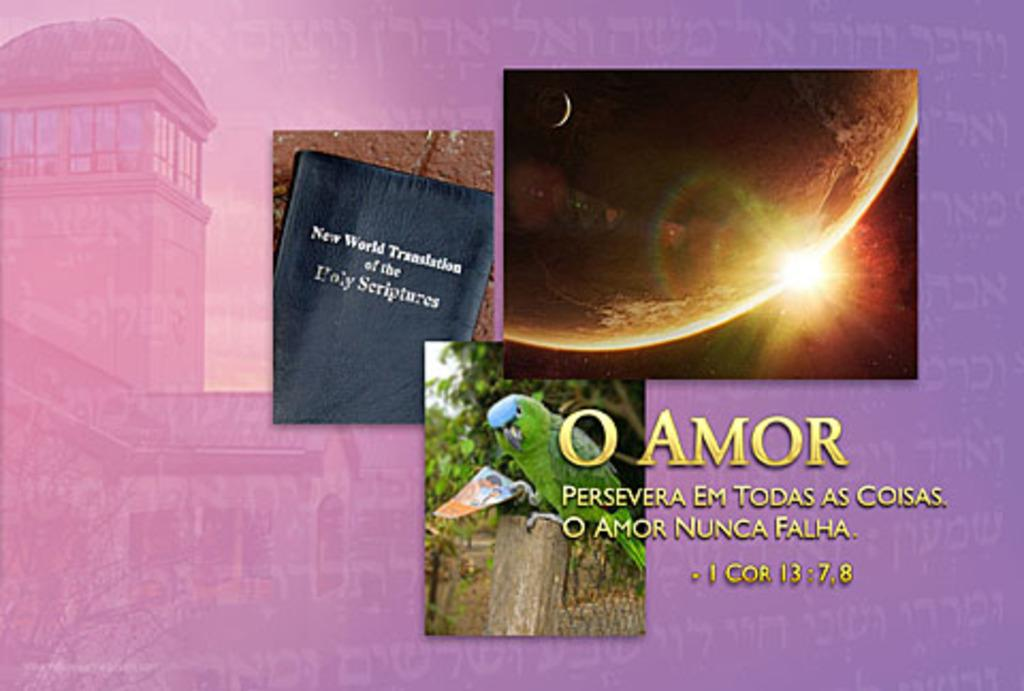<image>
Render a clear and concise summary of the photo. New world translation of the Holy scriptures book. 